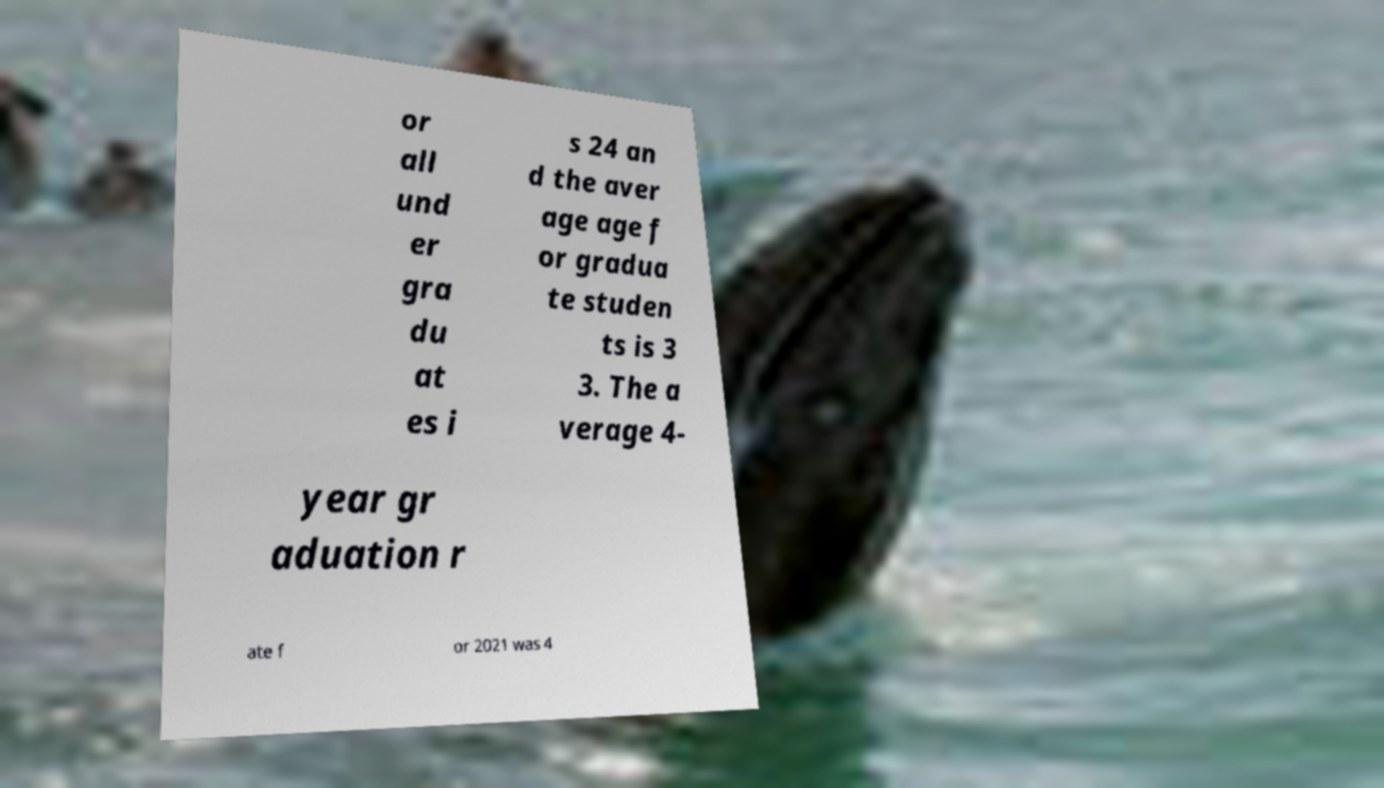What messages or text are displayed in this image? I need them in a readable, typed format. or all und er gra du at es i s 24 an d the aver age age f or gradua te studen ts is 3 3. The a verage 4- year gr aduation r ate f or 2021 was 4 